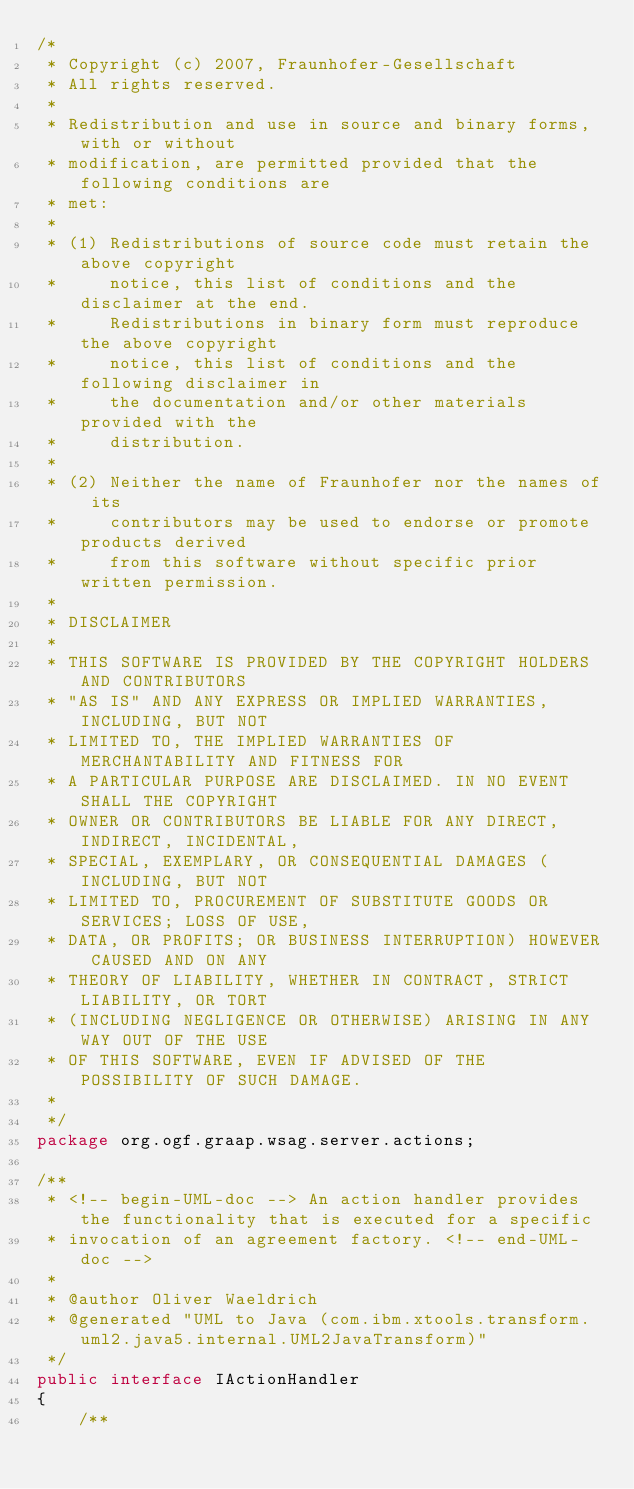Convert code to text. <code><loc_0><loc_0><loc_500><loc_500><_Java_>/* 
 * Copyright (c) 2007, Fraunhofer-Gesellschaft
 * All rights reserved.
 * 
 * Redistribution and use in source and binary forms, with or without
 * modification, are permitted provided that the following conditions are
 * met:
 * 
 * (1) Redistributions of source code must retain the above copyright
 *     notice, this list of conditions and the disclaimer at the end.
 *     Redistributions in binary form must reproduce the above copyright
 *     notice, this list of conditions and the following disclaimer in
 *     the documentation and/or other materials provided with the
 *     distribution.
 * 
 * (2) Neither the name of Fraunhofer nor the names of its
 *     contributors may be used to endorse or promote products derived
 *     from this software without specific prior written permission.
 * 
 * DISCLAIMER
 * 
 * THIS SOFTWARE IS PROVIDED BY THE COPYRIGHT HOLDERS AND CONTRIBUTORS
 * "AS IS" AND ANY EXPRESS OR IMPLIED WARRANTIES, INCLUDING, BUT NOT
 * LIMITED TO, THE IMPLIED WARRANTIES OF MERCHANTABILITY AND FITNESS FOR
 * A PARTICULAR PURPOSE ARE DISCLAIMED. IN NO EVENT SHALL THE COPYRIGHT
 * OWNER OR CONTRIBUTORS BE LIABLE FOR ANY DIRECT, INDIRECT, INCIDENTAL,
 * SPECIAL, EXEMPLARY, OR CONSEQUENTIAL DAMAGES (INCLUDING, BUT NOT
 * LIMITED TO, PROCUREMENT OF SUBSTITUTE GOODS OR SERVICES; LOSS OF USE,
 * DATA, OR PROFITS; OR BUSINESS INTERRUPTION) HOWEVER CAUSED AND ON ANY
 * THEORY OF LIABILITY, WHETHER IN CONTRACT, STRICT LIABILITY, OR TORT
 * (INCLUDING NEGLIGENCE OR OTHERWISE) ARISING IN ANY WAY OUT OF THE USE
 * OF THIS SOFTWARE, EVEN IF ADVISED OF THE POSSIBILITY OF SUCH DAMAGE.
 *  
 */
package org.ogf.graap.wsag.server.actions;

/**
 * <!-- begin-UML-doc --> An action handler provides the functionality that is executed for a specific
 * invocation of an agreement factory. <!-- end-UML-doc -->
 * 
 * @author Oliver Waeldrich
 * @generated "UML to Java (com.ibm.xtools.transform.uml2.java5.internal.UML2JavaTransform)"
 */
public interface IActionHandler
{
    /**</code> 